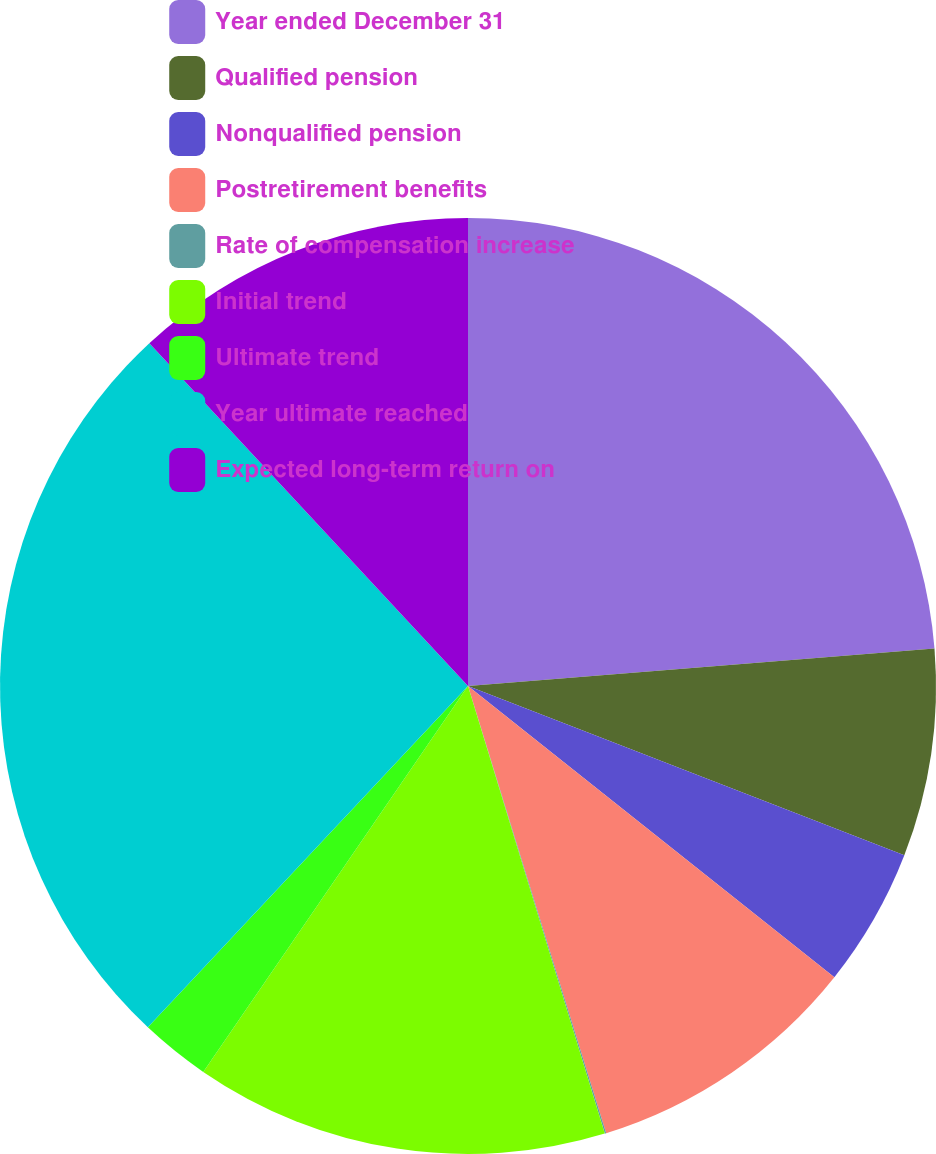Convert chart to OTSL. <chart><loc_0><loc_0><loc_500><loc_500><pie_chart><fcel>Year ended December 31<fcel>Qualified pension<fcel>Nonqualified pension<fcel>Postretirement benefits<fcel>Rate of compensation increase<fcel>Initial trend<fcel>Ultimate trend<fcel>Year ultimate reached<fcel>Expected long-term return on<nl><fcel>23.72%<fcel>7.17%<fcel>4.8%<fcel>9.54%<fcel>0.05%<fcel>14.29%<fcel>2.42%<fcel>26.09%<fcel>11.92%<nl></chart> 